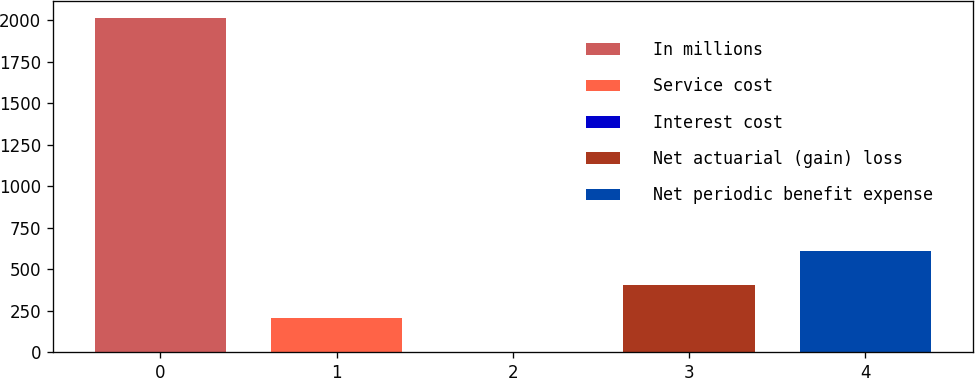<chart> <loc_0><loc_0><loc_500><loc_500><bar_chart><fcel>In millions<fcel>Service cost<fcel>Interest cost<fcel>Net actuarial (gain) loss<fcel>Net periodic benefit expense<nl><fcel>2016<fcel>205.29<fcel>4.1<fcel>406.48<fcel>607.67<nl></chart> 